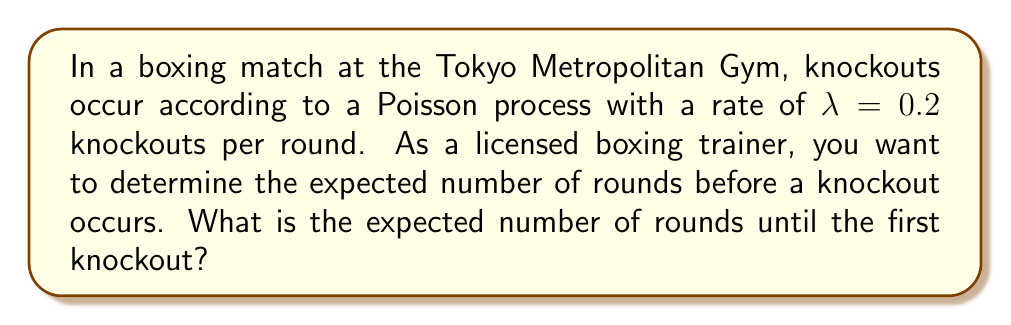Can you answer this question? To solve this problem, we'll use the properties of the Poisson process:

1) In a Poisson process, the time until the first event (in this case, a knockout) follows an exponential distribution.

2) For an exponential distribution with rate parameter $\lambda$, the expected value (mean) is given by $\frac{1}{\lambda}$.

3) In our case, $\lambda = 0.2$ knockouts per round.

4) Therefore, the expected number of rounds until the first knockout is:

   $$E[X] = \frac{1}{\lambda} = \frac{1}{0.2} = 5$$

5) This means that, on average, we expect a knockout to occur after 5 rounds.

Note: This is a continuous approximation of what is actually a discrete process (as rounds are discrete units). However, it provides a good estimate for planning purposes.
Answer: 5 rounds 